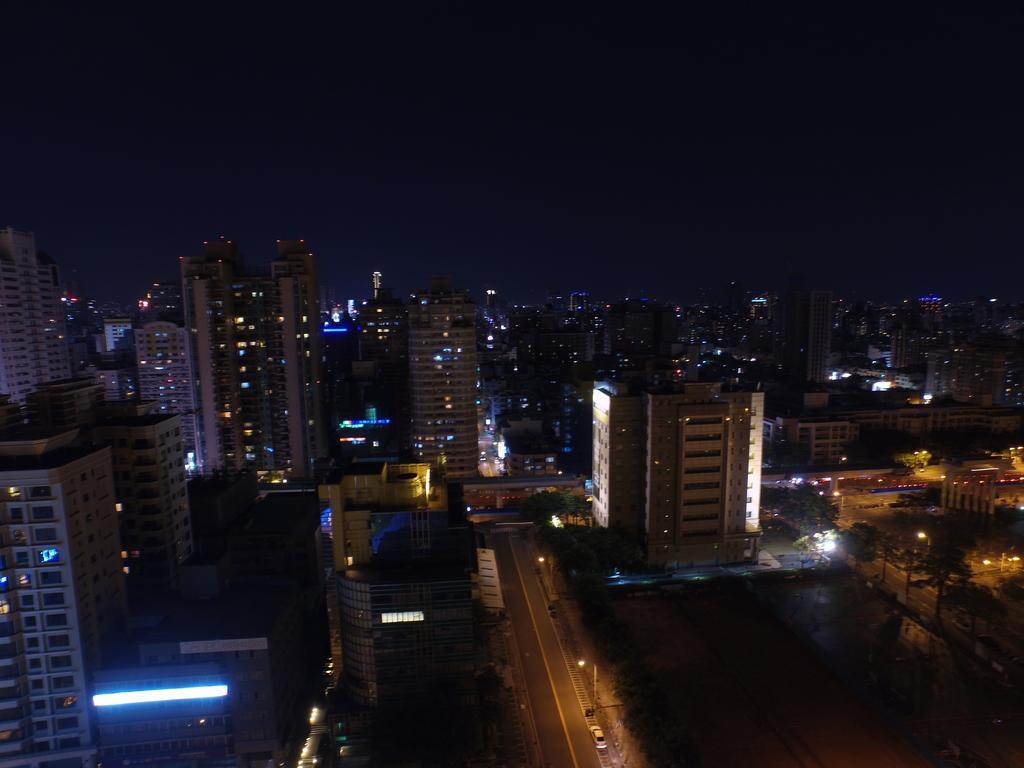Could you give a brief overview of what you see in this image? In this image, we can see some buildings, poles, lights, trees. We can see the ground with some objects. We can see a vehicle and the dark sky. 